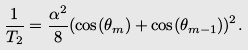Convert formula to latex. <formula><loc_0><loc_0><loc_500><loc_500>\frac { 1 } { T _ { 2 } } = \frac { \alpha ^ { 2 } } { 8 } ( \cos ( \theta _ { m } ) + \cos ( \theta _ { m - 1 } ) ) ^ { 2 } .</formula> 